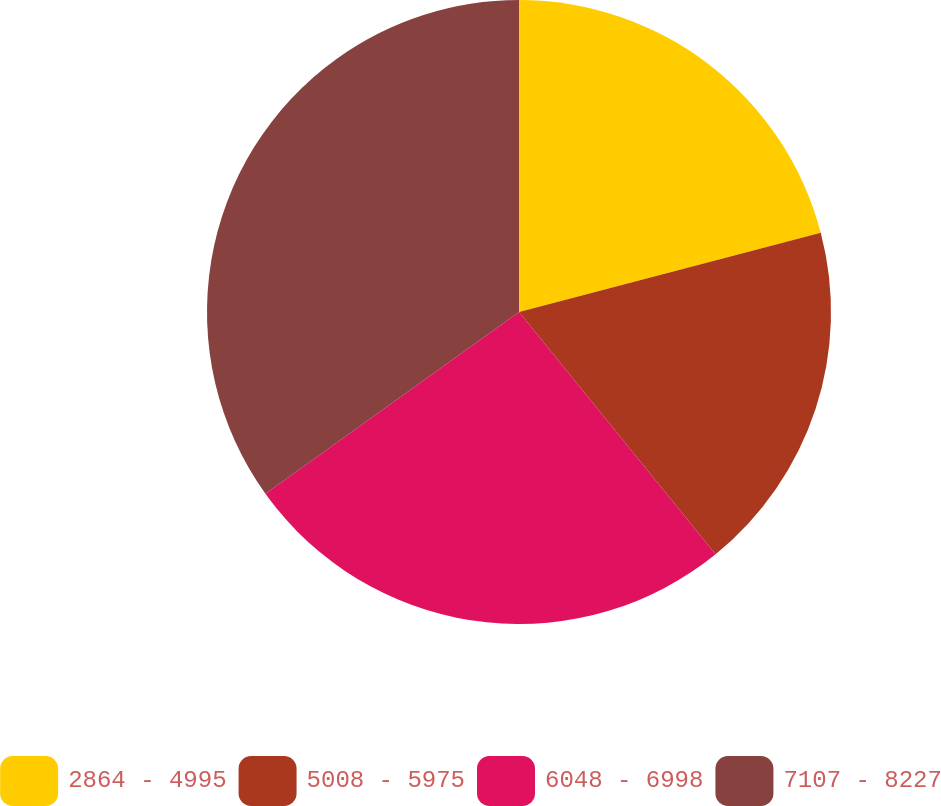Convert chart to OTSL. <chart><loc_0><loc_0><loc_500><loc_500><pie_chart><fcel>2864 - 4995<fcel>5008 - 5975<fcel>6048 - 6998<fcel>7107 - 8227<nl><fcel>20.91%<fcel>18.24%<fcel>25.95%<fcel>34.9%<nl></chart> 